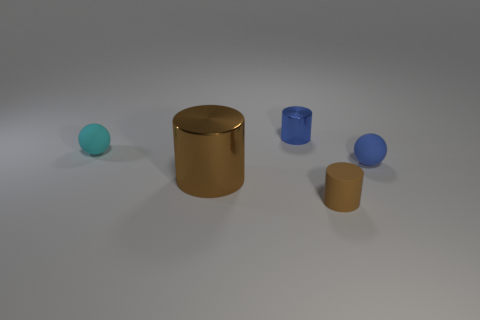There is a big object that is the same color as the rubber cylinder; what material is it?
Give a very brief answer. Metal. There is a cyan thing that is the same size as the blue rubber thing; what is it made of?
Offer a terse response. Rubber. Are there any matte cylinders of the same size as the blue rubber object?
Provide a succinct answer. Yes. What is the color of the big object?
Make the answer very short. Brown. The small matte object to the left of the brown cylinder that is in front of the large thing is what color?
Offer a terse response. Cyan. The small thing behind the sphere left of the tiny rubber ball right of the brown rubber object is what shape?
Keep it short and to the point. Cylinder. How many balls are made of the same material as the tiny brown cylinder?
Your answer should be compact. 2. There is a brown cylinder right of the tiny blue metallic cylinder; how many large brown cylinders are to the right of it?
Offer a terse response. 0. How many brown matte cylinders are there?
Offer a terse response. 1. Is the large thing made of the same material as the thing to the left of the large shiny object?
Keep it short and to the point. No. 